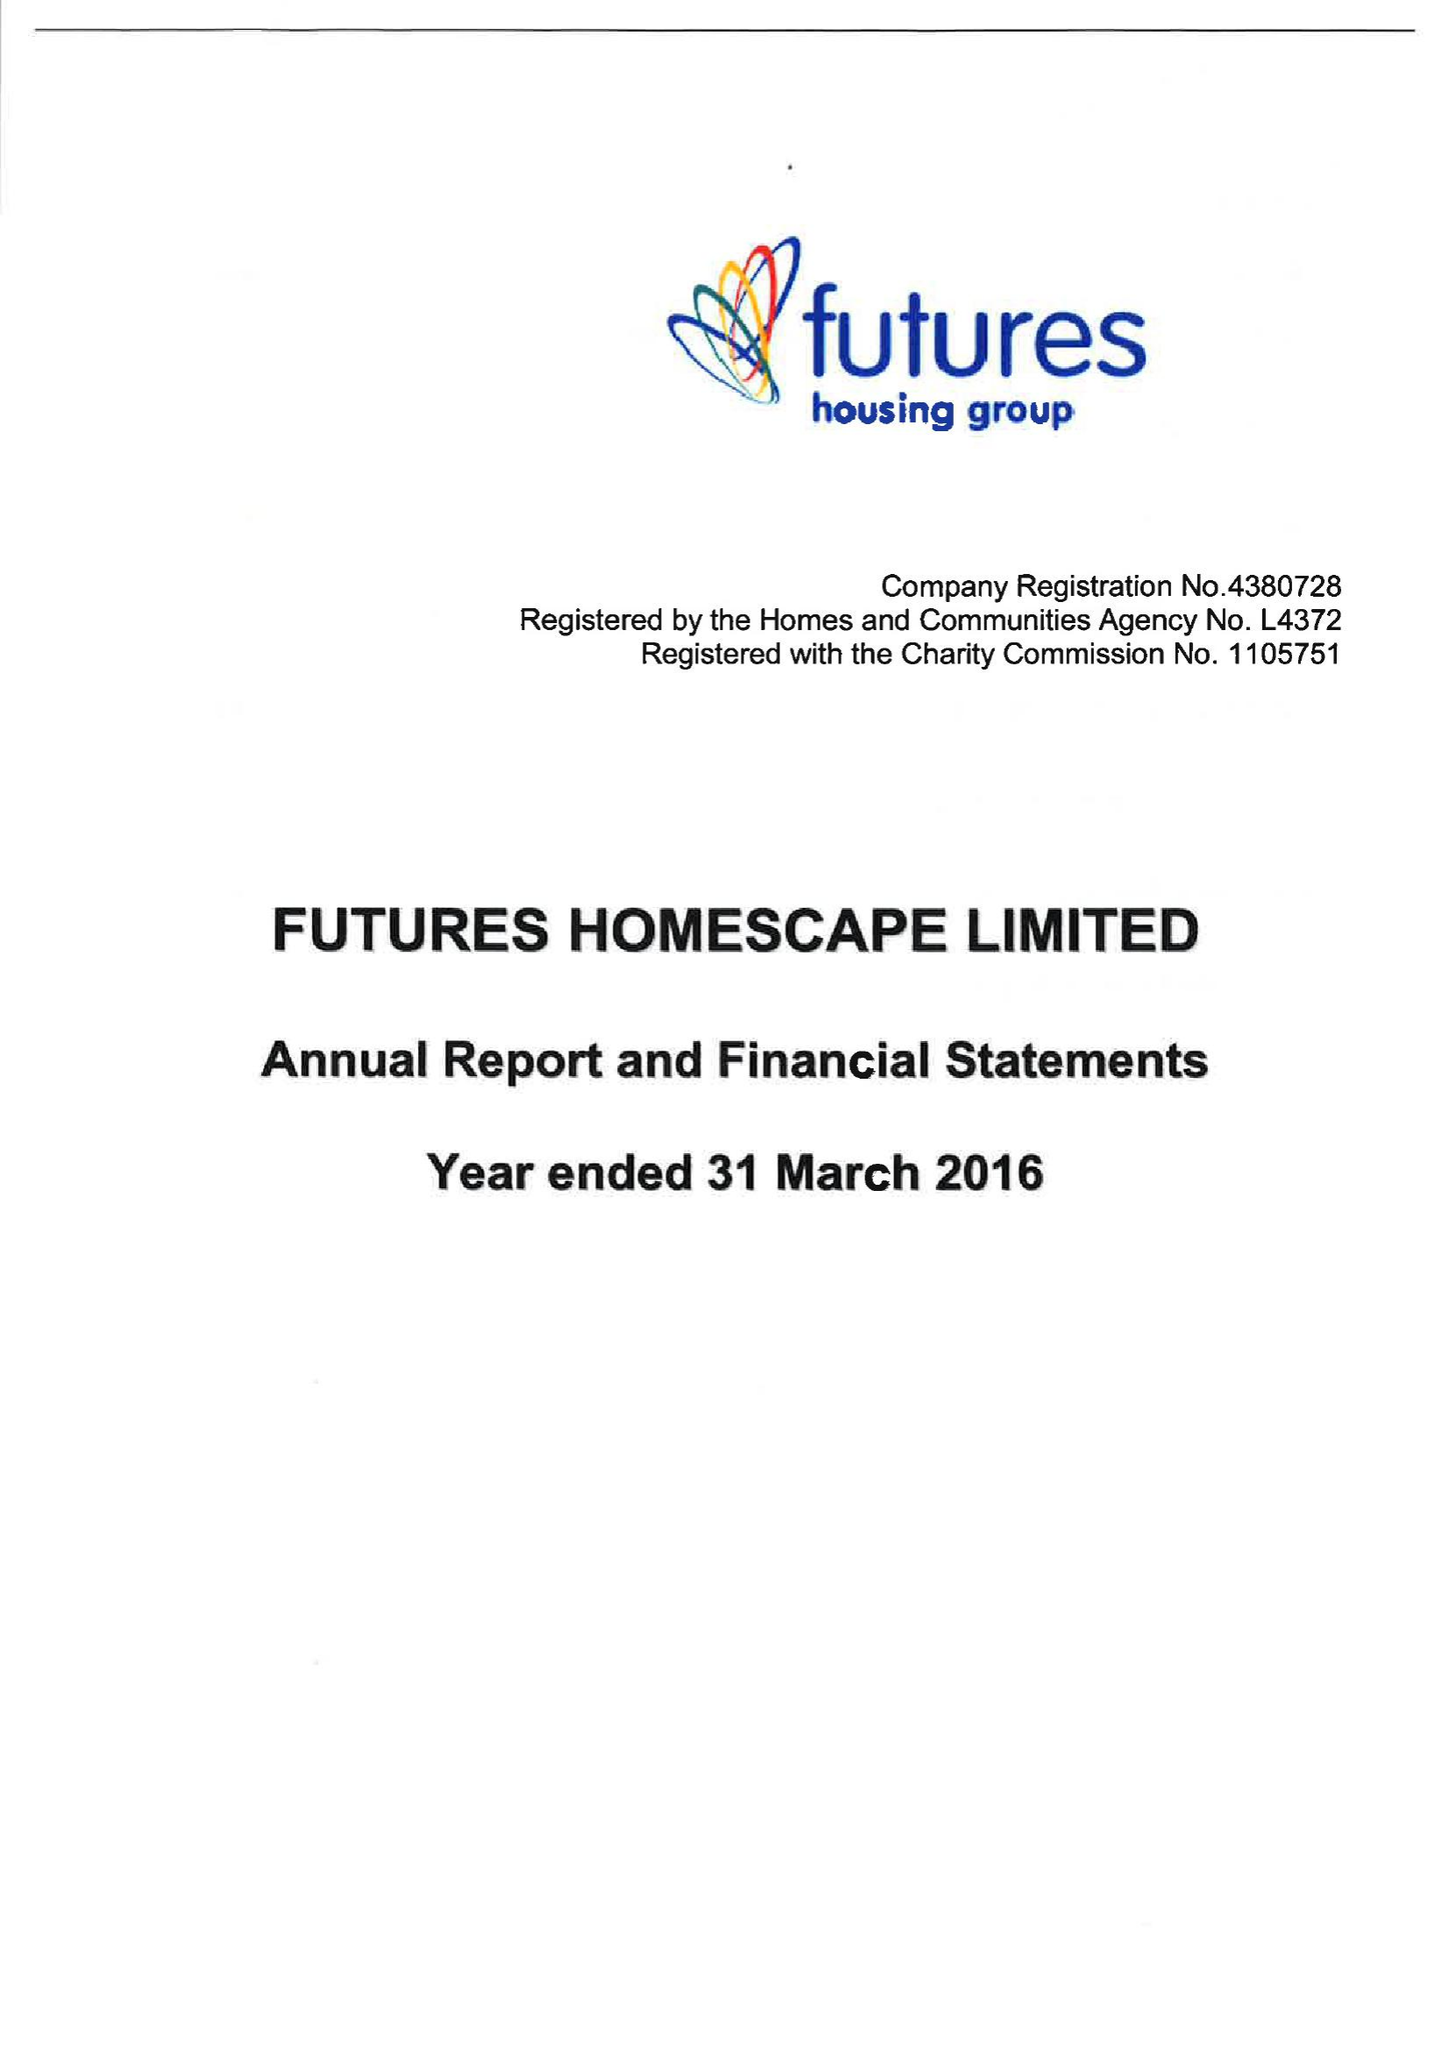What is the value for the report_date?
Answer the question using a single word or phrase. 2016-03-31 